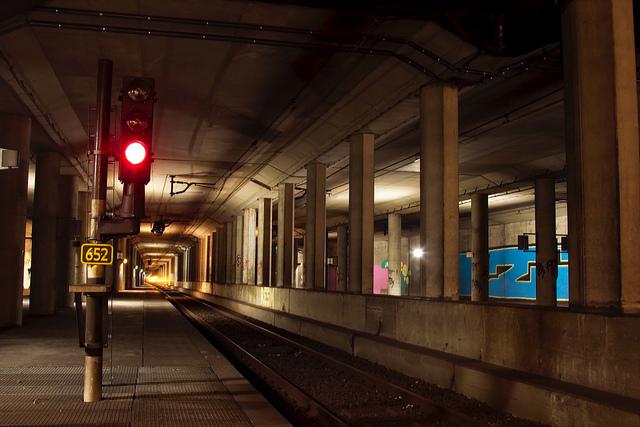Is a train coming?
Quick response, please. Yes. What number is on the traffic light?
Be succinct. 652. What is painted on the wall on the right?
Be succinct. Mural. Do you see street lights?
Answer briefly. No. Is there a convenient place to lock up a bike here?
Give a very brief answer. No. 